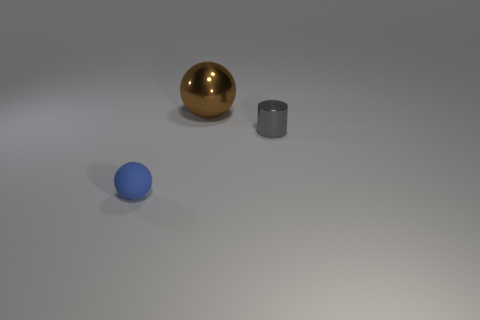What time of day does the lighting in this image suggest? The lighting in the image is soft and diffused, with no hard shadows or high contrast typically seen in natural sunlight. It suggests an interior environment potentially illuminated by studio lights or an overcast day where sunlight is scattered by clouds, leading to even lighting throughout the scene. 